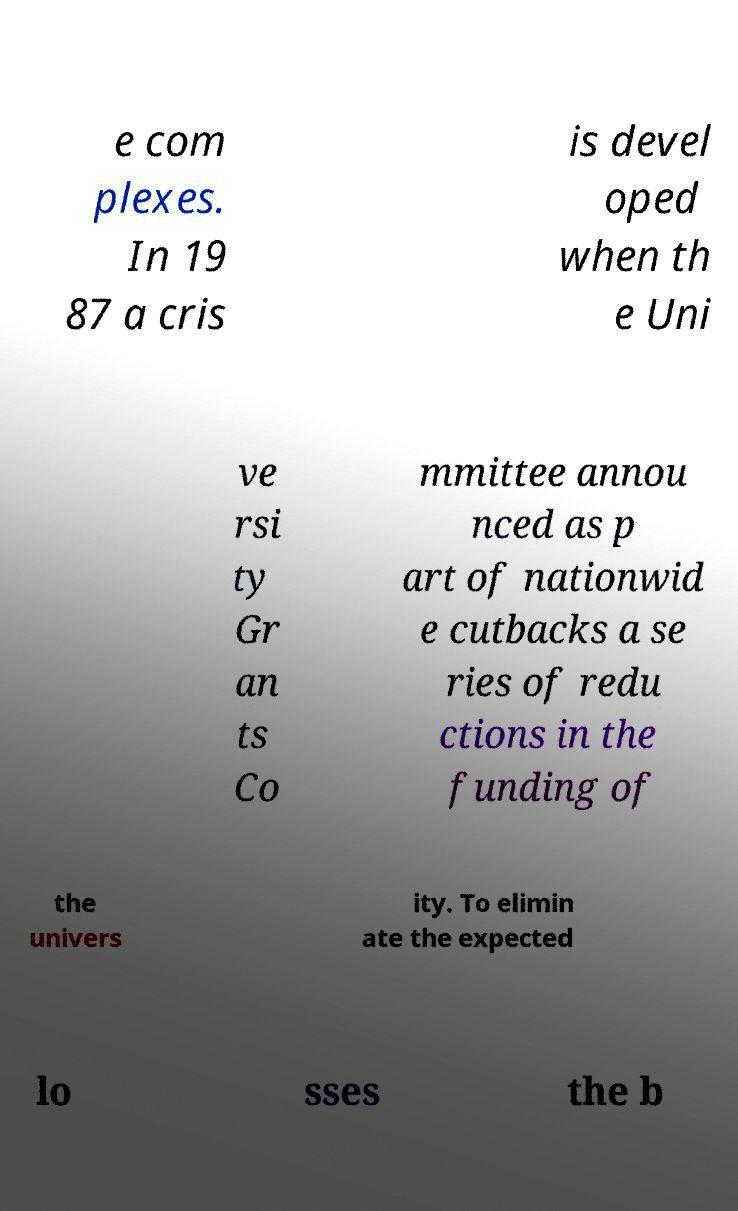Could you assist in decoding the text presented in this image and type it out clearly? e com plexes. In 19 87 a cris is devel oped when th e Uni ve rsi ty Gr an ts Co mmittee annou nced as p art of nationwid e cutbacks a se ries of redu ctions in the funding of the univers ity. To elimin ate the expected lo sses the b 